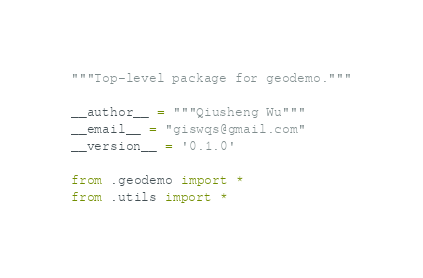Convert code to text. <code><loc_0><loc_0><loc_500><loc_500><_Python_>"""Top-level package for geodemo."""

__author__ = """Qiusheng Wu"""
__email__ = "giswqs@gmail.com"
__version__ = '0.1.0'

from .geodemo import *
from .utils import *
</code> 